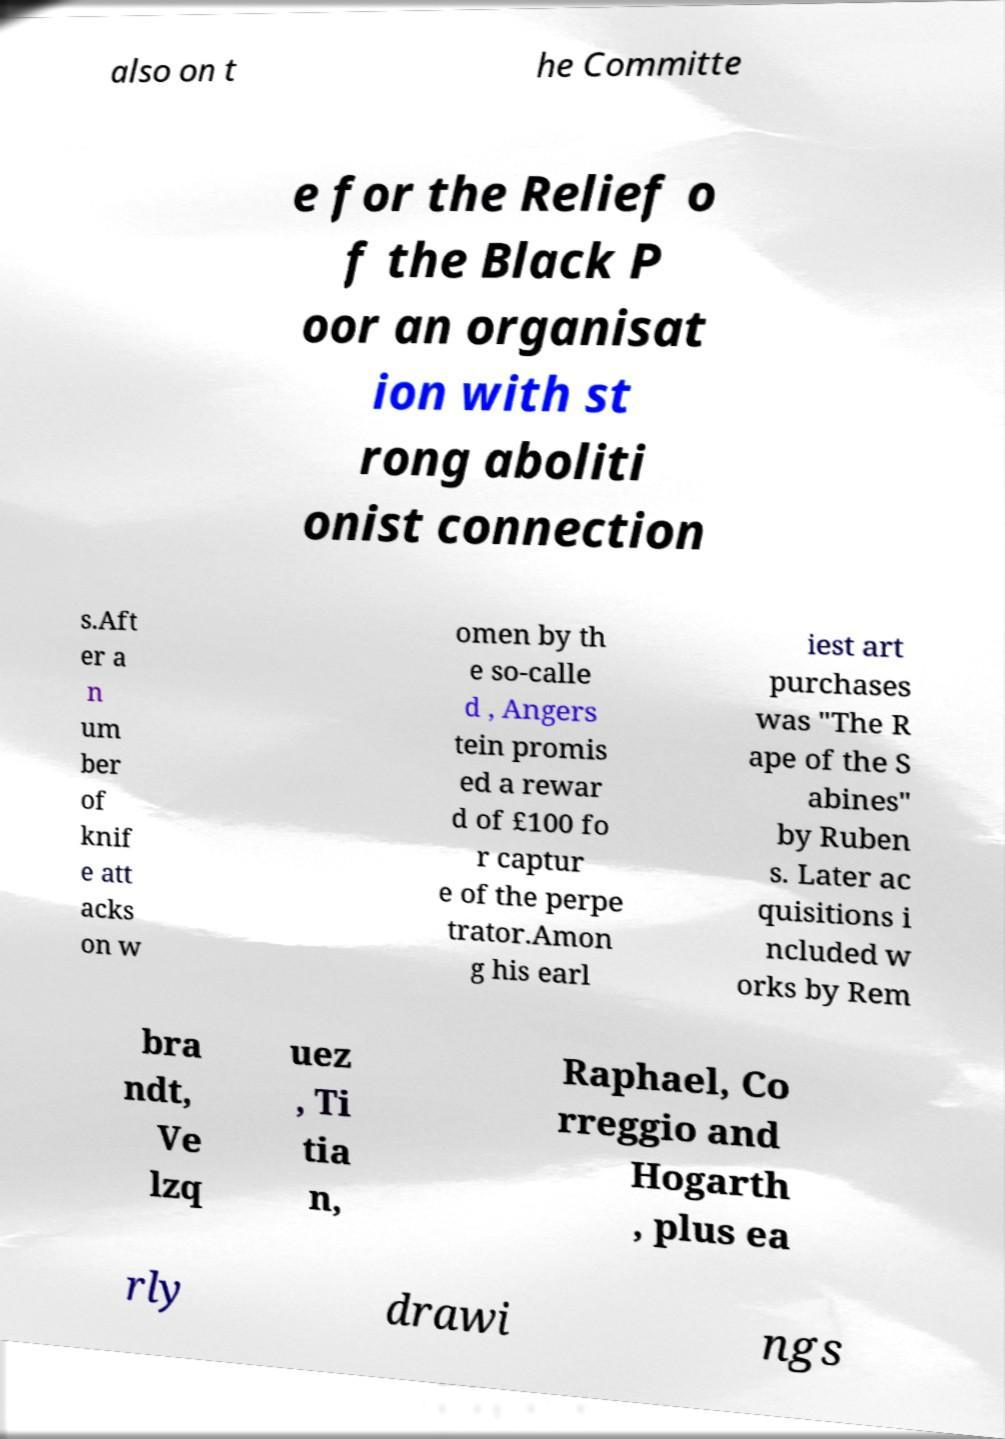Can you accurately transcribe the text from the provided image for me? also on t he Committe e for the Relief o f the Black P oor an organisat ion with st rong aboliti onist connection s.Aft er a n um ber of knif e att acks on w omen by th e so-calle d , Angers tein promis ed a rewar d of £100 fo r captur e of the perpe trator.Amon g his earl iest art purchases was "The R ape of the S abines" by Ruben s. Later ac quisitions i ncluded w orks by Rem bra ndt, Ve lzq uez , Ti tia n, Raphael, Co rreggio and Hogarth , plus ea rly drawi ngs 